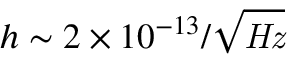Convert formula to latex. <formula><loc_0><loc_0><loc_500><loc_500>h \sim { 2 \times 1 0 ^ { - 1 3 } / { \sqrt { H z } } }</formula> 